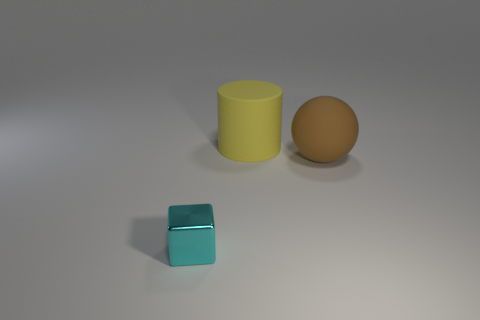Add 3 brown balls. How many objects exist? 6 Subtract 1 blocks. How many blocks are left? 0 Subtract 0 blue blocks. How many objects are left? 3 Subtract all cubes. How many objects are left? 2 Subtract all yellow balls. Subtract all brown cubes. How many balls are left? 1 Subtract all tiny red matte cubes. Subtract all yellow rubber cylinders. How many objects are left? 2 Add 3 balls. How many balls are left? 4 Add 2 big brown matte objects. How many big brown matte objects exist? 3 